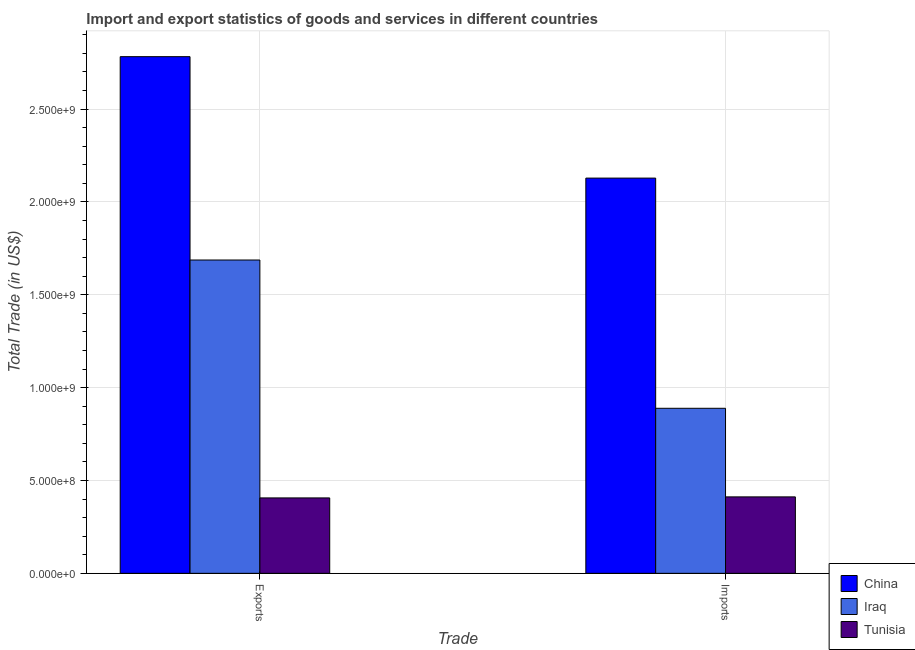Are the number of bars per tick equal to the number of legend labels?
Ensure brevity in your answer.  Yes. Are the number of bars on each tick of the X-axis equal?
Your answer should be compact. Yes. How many bars are there on the 2nd tick from the left?
Your response must be concise. 3. How many bars are there on the 2nd tick from the right?
Give a very brief answer. 3. What is the label of the 2nd group of bars from the left?
Ensure brevity in your answer.  Imports. What is the export of goods and services in Iraq?
Keep it short and to the point. 1.69e+09. Across all countries, what is the maximum imports of goods and services?
Your answer should be very brief. 2.13e+09. Across all countries, what is the minimum imports of goods and services?
Your answer should be very brief. 4.12e+08. In which country was the imports of goods and services minimum?
Offer a very short reply. Tunisia. What is the total export of goods and services in the graph?
Provide a succinct answer. 4.88e+09. What is the difference between the imports of goods and services in China and that in Iraq?
Your answer should be very brief. 1.24e+09. What is the difference between the export of goods and services in Tunisia and the imports of goods and services in China?
Provide a short and direct response. -1.72e+09. What is the average export of goods and services per country?
Your response must be concise. 1.63e+09. What is the difference between the export of goods and services and imports of goods and services in China?
Your answer should be compact. 6.54e+08. In how many countries, is the imports of goods and services greater than 1300000000 US$?
Your answer should be very brief. 1. What is the ratio of the imports of goods and services in Iraq to that in Tunisia?
Offer a very short reply. 2.16. What does the 3rd bar from the left in Exports represents?
Provide a short and direct response. Tunisia. What does the 2nd bar from the right in Exports represents?
Keep it short and to the point. Iraq. How many bars are there?
Ensure brevity in your answer.  6. How many countries are there in the graph?
Your answer should be very brief. 3. Are the values on the major ticks of Y-axis written in scientific E-notation?
Provide a succinct answer. Yes. Does the graph contain grids?
Provide a succinct answer. Yes. What is the title of the graph?
Ensure brevity in your answer.  Import and export statistics of goods and services in different countries. What is the label or title of the X-axis?
Offer a very short reply. Trade. What is the label or title of the Y-axis?
Your answer should be very brief. Total Trade (in US$). What is the Total Trade (in US$) in China in Exports?
Your answer should be very brief. 2.78e+09. What is the Total Trade (in US$) of Iraq in Exports?
Give a very brief answer. 1.69e+09. What is the Total Trade (in US$) of Tunisia in Exports?
Provide a short and direct response. 4.06e+08. What is the Total Trade (in US$) in China in Imports?
Your response must be concise. 2.13e+09. What is the Total Trade (in US$) of Iraq in Imports?
Offer a terse response. 8.89e+08. What is the Total Trade (in US$) of Tunisia in Imports?
Your response must be concise. 4.12e+08. Across all Trade, what is the maximum Total Trade (in US$) in China?
Give a very brief answer. 2.78e+09. Across all Trade, what is the maximum Total Trade (in US$) in Iraq?
Provide a short and direct response. 1.69e+09. Across all Trade, what is the maximum Total Trade (in US$) in Tunisia?
Provide a short and direct response. 4.12e+08. Across all Trade, what is the minimum Total Trade (in US$) of China?
Ensure brevity in your answer.  2.13e+09. Across all Trade, what is the minimum Total Trade (in US$) of Iraq?
Offer a terse response. 8.89e+08. Across all Trade, what is the minimum Total Trade (in US$) of Tunisia?
Keep it short and to the point. 4.06e+08. What is the total Total Trade (in US$) of China in the graph?
Your answer should be compact. 4.91e+09. What is the total Total Trade (in US$) of Iraq in the graph?
Your answer should be very brief. 2.58e+09. What is the total Total Trade (in US$) in Tunisia in the graph?
Your answer should be compact. 8.18e+08. What is the difference between the Total Trade (in US$) of China in Exports and that in Imports?
Offer a very short reply. 6.54e+08. What is the difference between the Total Trade (in US$) of Iraq in Exports and that in Imports?
Ensure brevity in your answer.  7.99e+08. What is the difference between the Total Trade (in US$) in Tunisia in Exports and that in Imports?
Offer a terse response. -5.55e+06. What is the difference between the Total Trade (in US$) in China in Exports and the Total Trade (in US$) in Iraq in Imports?
Offer a terse response. 1.89e+09. What is the difference between the Total Trade (in US$) of China in Exports and the Total Trade (in US$) of Tunisia in Imports?
Your response must be concise. 2.37e+09. What is the difference between the Total Trade (in US$) in Iraq in Exports and the Total Trade (in US$) in Tunisia in Imports?
Your answer should be very brief. 1.28e+09. What is the average Total Trade (in US$) in China per Trade?
Provide a short and direct response. 2.46e+09. What is the average Total Trade (in US$) in Iraq per Trade?
Provide a succinct answer. 1.29e+09. What is the average Total Trade (in US$) of Tunisia per Trade?
Your response must be concise. 4.09e+08. What is the difference between the Total Trade (in US$) of China and Total Trade (in US$) of Iraq in Exports?
Give a very brief answer. 1.10e+09. What is the difference between the Total Trade (in US$) of China and Total Trade (in US$) of Tunisia in Exports?
Your answer should be very brief. 2.38e+09. What is the difference between the Total Trade (in US$) of Iraq and Total Trade (in US$) of Tunisia in Exports?
Provide a succinct answer. 1.28e+09. What is the difference between the Total Trade (in US$) of China and Total Trade (in US$) of Iraq in Imports?
Give a very brief answer. 1.24e+09. What is the difference between the Total Trade (in US$) in China and Total Trade (in US$) in Tunisia in Imports?
Keep it short and to the point. 1.72e+09. What is the difference between the Total Trade (in US$) of Iraq and Total Trade (in US$) of Tunisia in Imports?
Ensure brevity in your answer.  4.77e+08. What is the ratio of the Total Trade (in US$) in China in Exports to that in Imports?
Offer a very short reply. 1.31. What is the ratio of the Total Trade (in US$) in Iraq in Exports to that in Imports?
Provide a succinct answer. 1.9. What is the ratio of the Total Trade (in US$) in Tunisia in Exports to that in Imports?
Your response must be concise. 0.99. What is the difference between the highest and the second highest Total Trade (in US$) of China?
Provide a short and direct response. 6.54e+08. What is the difference between the highest and the second highest Total Trade (in US$) of Iraq?
Ensure brevity in your answer.  7.99e+08. What is the difference between the highest and the second highest Total Trade (in US$) of Tunisia?
Offer a very short reply. 5.55e+06. What is the difference between the highest and the lowest Total Trade (in US$) in China?
Provide a short and direct response. 6.54e+08. What is the difference between the highest and the lowest Total Trade (in US$) in Iraq?
Your answer should be compact. 7.99e+08. What is the difference between the highest and the lowest Total Trade (in US$) in Tunisia?
Give a very brief answer. 5.55e+06. 